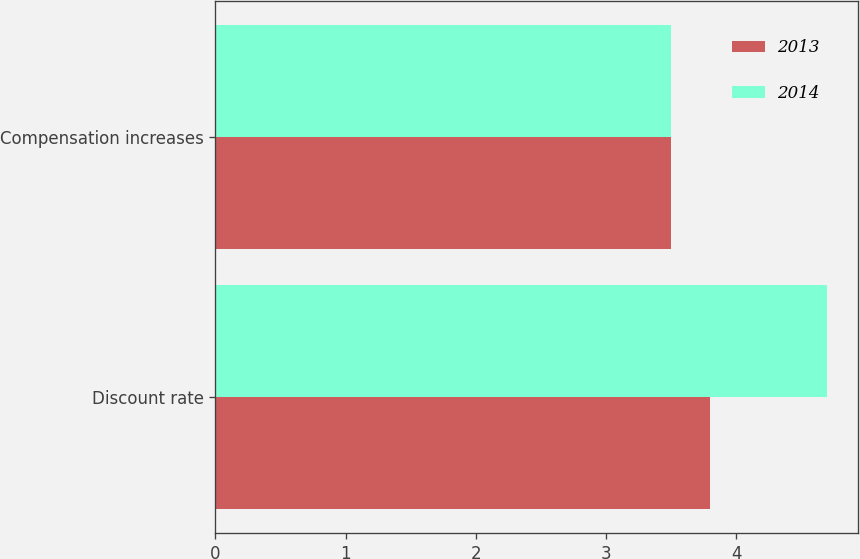<chart> <loc_0><loc_0><loc_500><loc_500><stacked_bar_chart><ecel><fcel>Discount rate<fcel>Compensation increases<nl><fcel>2013<fcel>3.8<fcel>3.5<nl><fcel>2014<fcel>4.7<fcel>3.5<nl></chart> 